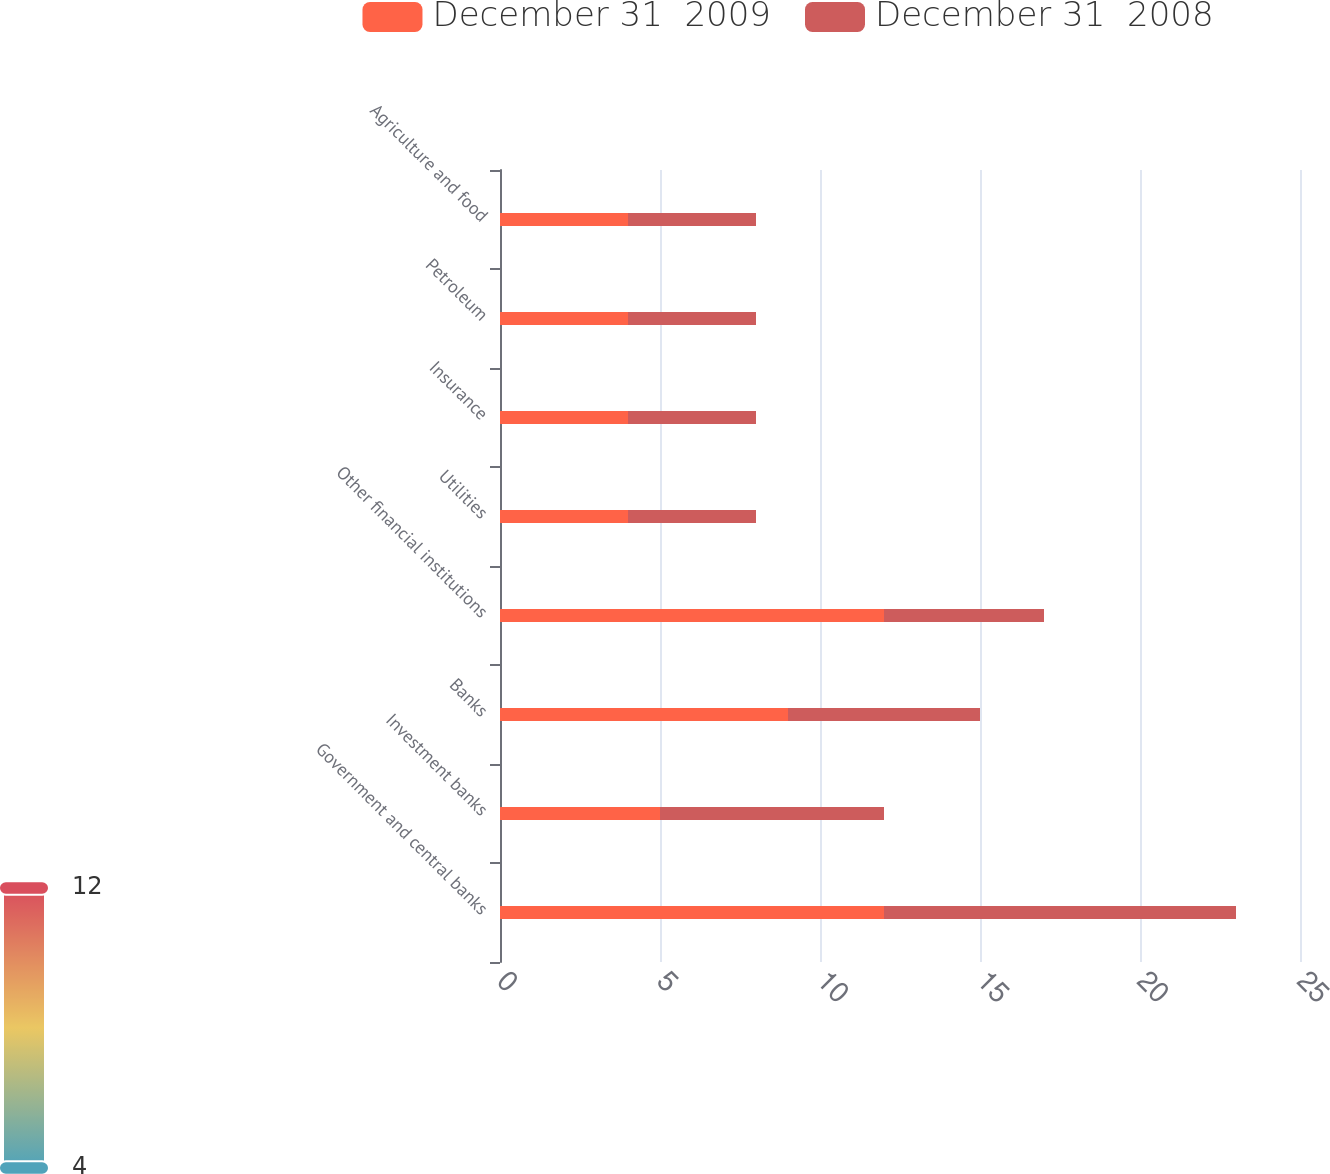Convert chart to OTSL. <chart><loc_0><loc_0><loc_500><loc_500><stacked_bar_chart><ecel><fcel>Government and central banks<fcel>Investment banks<fcel>Banks<fcel>Other financial institutions<fcel>Utilities<fcel>Insurance<fcel>Petroleum<fcel>Agriculture and food<nl><fcel>December 31  2009<fcel>12<fcel>5<fcel>9<fcel>12<fcel>4<fcel>4<fcel>4<fcel>4<nl><fcel>December 31  2008<fcel>11<fcel>7<fcel>6<fcel>5<fcel>4<fcel>4<fcel>4<fcel>4<nl></chart> 